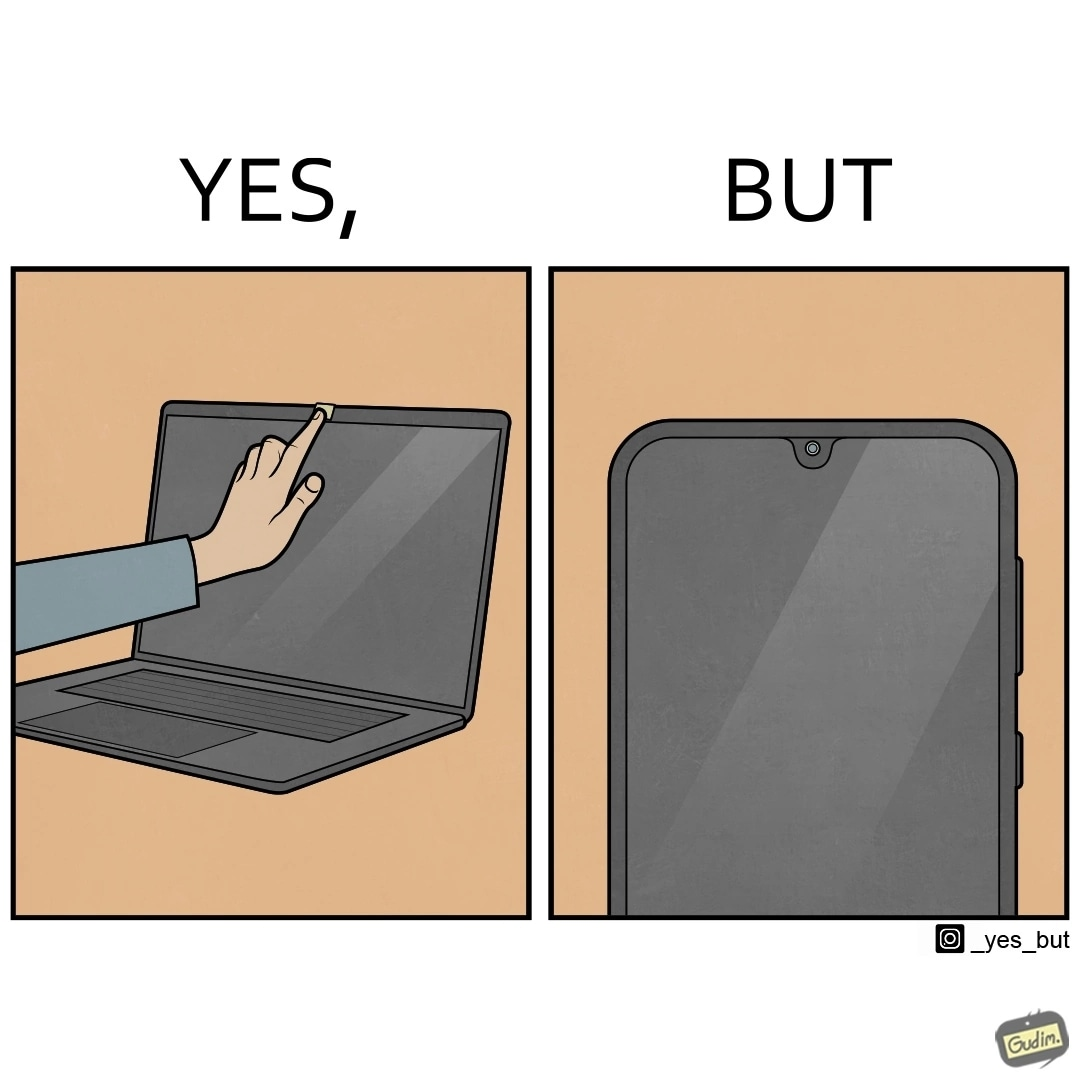Describe the contrast between the left and right parts of this image. In the left part of the image: a person applying tape over a laptop's camera In the right part of the image: a smartphone screen 